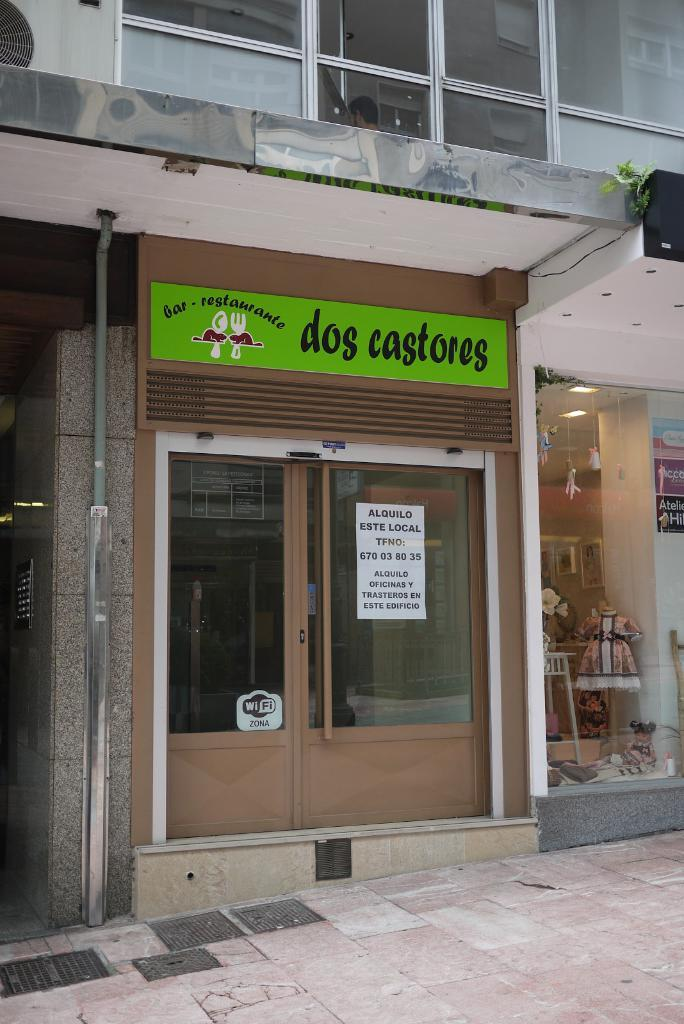What can be seen at the bottom of the image? The ground is visible in the image. What is located in the distance in the image? There is a building in the background of the image. Can you describe any other elements in the background of the image? There are some unspecified objects in the background of the image. What type of fruit is hanging from the clock in the image? There is no clock or fruit present in the image. What kind of trouble is the person in the image experiencing? There is no person or trouble depicted in the image. 